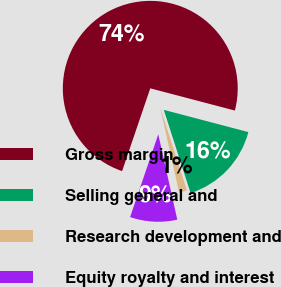Convert chart to OTSL. <chart><loc_0><loc_0><loc_500><loc_500><pie_chart><fcel>Gross margin<fcel>Selling general and<fcel>Research development and<fcel>Equity royalty and interest<nl><fcel>73.87%<fcel>15.95%<fcel>1.47%<fcel>8.71%<nl></chart> 